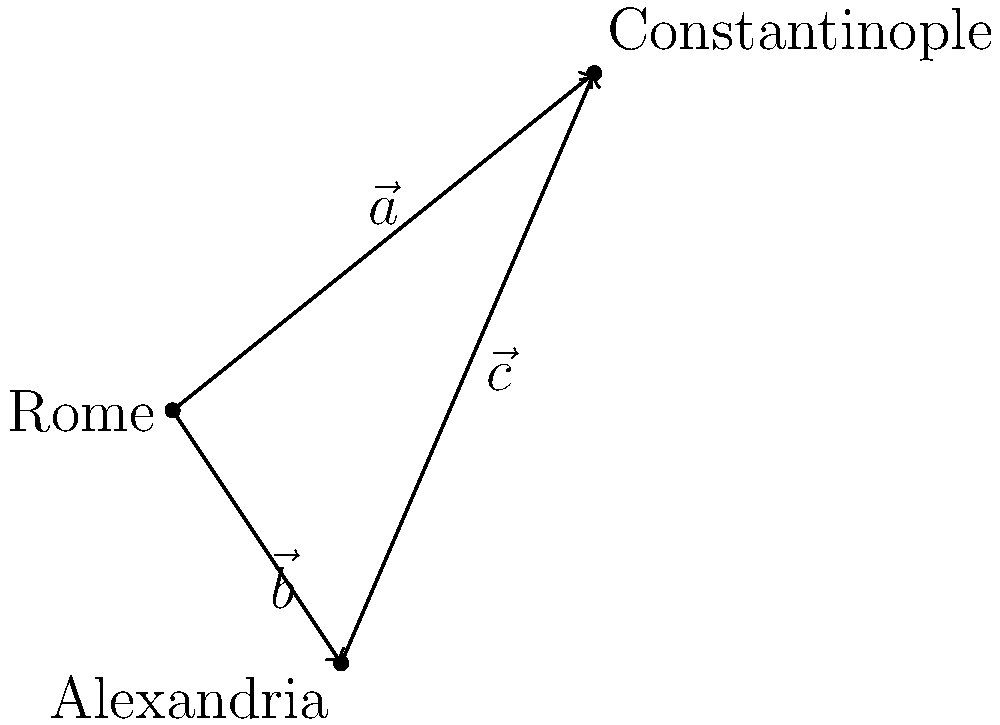In the given vector representation of ancient trade routes, $\vec{a}$ represents the route from Rome to Constantinople, $\vec{b}$ represents the route from Rome to Alexandria, and $\vec{c}$ represents the route from Alexandria to Constantinople. Which vector equation correctly describes the relationship between these trade routes? To solve this problem, let's follow these steps:

1. Analyze the diagram: We see three vectors forming a triangle between Rome, Constantinople, and Alexandria.

2. Understand vector addition: When we add vectors, we follow the tip-to-tail method. The sum of two vectors that form two sides of a triangle is equal to the third side of the triangle.

3. Identify the relationship: 
   - $\vec{a}$ goes from Rome to Constantinople
   - $\vec{b}$ goes from Rome to Alexandria
   - $\vec{c}$ goes from Alexandria to Constantinople

4. Form the equation: To get from Rome to Constantinople, we can either go directly ($\vec{a}$) or go through Alexandria ($\vec{b}$ + $\vec{c}$).

5. Write the vector equation: $\vec{a} = \vec{b} + \vec{c}$

This equation shows that the direct route from Rome to Constantinople ($\vec{a}$) is equivalent to first traveling from Rome to Alexandria ($\vec{b}$) and then from Alexandria to Constantinople ($\vec{c}$).
Answer: $\vec{a} = \vec{b} + \vec{c}$ 